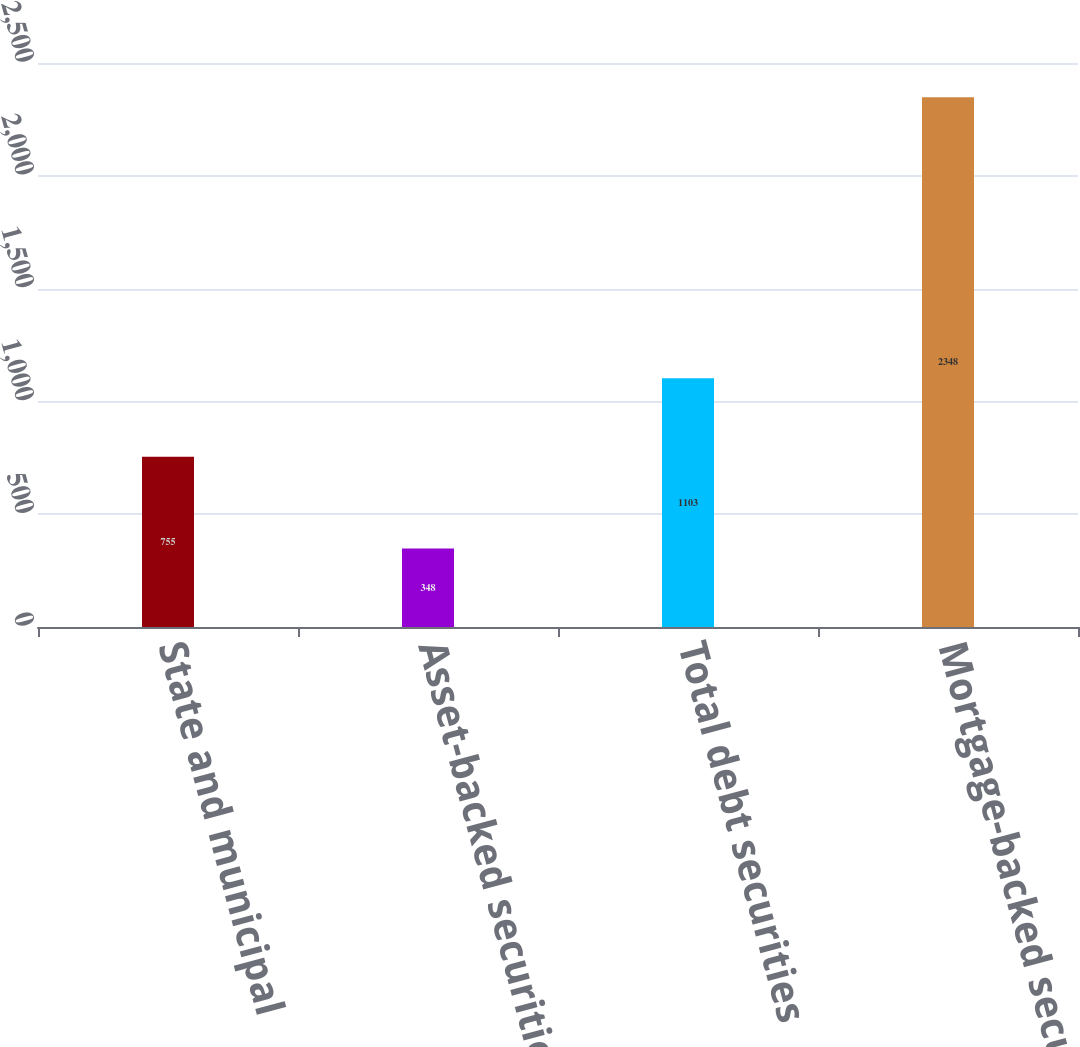Convert chart to OTSL. <chart><loc_0><loc_0><loc_500><loc_500><bar_chart><fcel>State and municipal<fcel>Asset-backed securities<fcel>Total debt securities<fcel>Mortgage-backed securities<nl><fcel>755<fcel>348<fcel>1103<fcel>2348<nl></chart> 